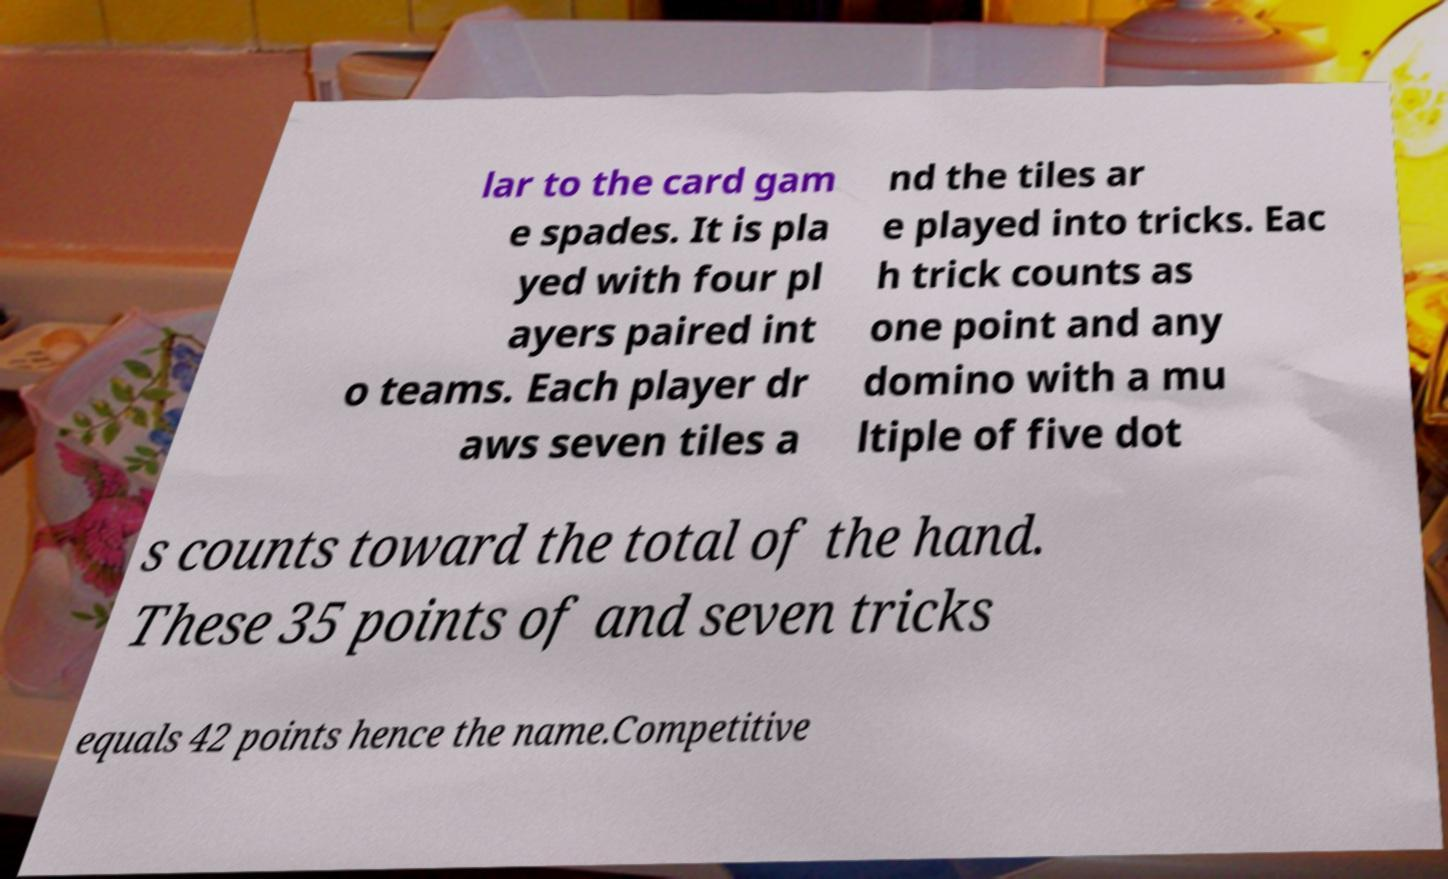Could you extract and type out the text from this image? lar to the card gam e spades. It is pla yed with four pl ayers paired int o teams. Each player dr aws seven tiles a nd the tiles ar e played into tricks. Eac h trick counts as one point and any domino with a mu ltiple of five dot s counts toward the total of the hand. These 35 points of and seven tricks equals 42 points hence the name.Competitive 